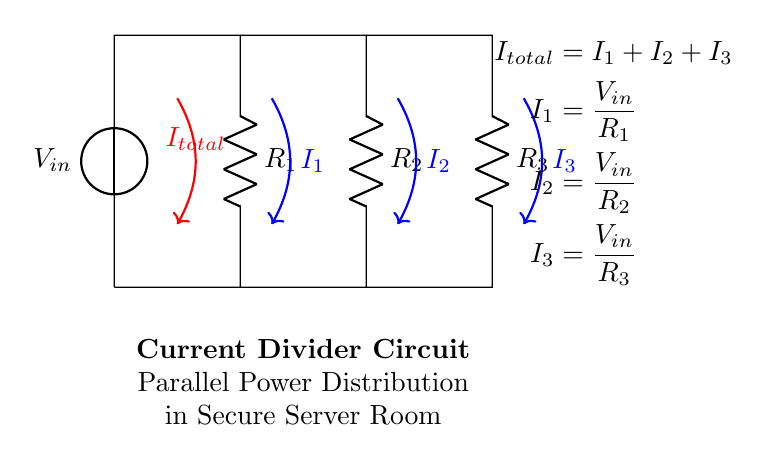What is the input voltage for the circuit? The circuit diagram labels the voltage source as V in, indicating that it is the input voltage.
Answer: V in How many resistors are in the circuit? The circuit diagram shows three resistors labeled R one, R two, and R three, which can be counted directly.
Answer: 3 What is the formula for the total current in the circuit? The total current is represented by I total in the diagram, and the formula given states that I total equals I one plus I two plus I three.
Answer: I total = I one + I two + I three What is the relationship between the currents I one, I two, and I three? The currents are inversely proportional to their respective resistances as described in the equations; the formula shows that each current is equal to the input voltage divided by its respective resistor value.
Answer: I one, I two, I three are inversely proportional to R one, R two, R three Which current has the highest value if R three has the lowest resistance? According to the current divider rule, the current through the resistor with the lowest resistance will be the highest, therefore I three will be the highest among I one, I two, and I three.
Answer: I three What happens to the total current if one resistor fails? If one resistor fails, the current divider effect is lost, resulting in an increased current through the remaining resistors, which could lead to overloads, depending on the system design.
Answer: Increased current through remaining resistors 